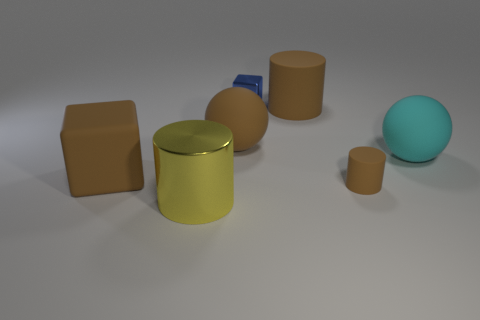Is there anything else that has the same color as the small cube?
Your response must be concise. No. There is a large brown rubber object that is to the left of the small blue object and to the right of the yellow object; what is its shape?
Make the answer very short. Sphere. Are there any things that are behind the tiny thing in front of the large object that is on the right side of the small brown matte thing?
Offer a very short reply. Yes. How many objects are either large objects in front of the small shiny block or brown matte objects right of the small blue metallic thing?
Ensure brevity in your answer.  6. Are the large cylinder that is behind the yellow metal thing and the tiny brown cylinder made of the same material?
Provide a succinct answer. Yes. What is the material of the object that is in front of the matte block and to the left of the tiny blue metal block?
Make the answer very short. Metal. There is a tiny thing that is in front of the rubber cube in front of the blue block; what color is it?
Keep it short and to the point. Brown. What material is the yellow thing that is the same shape as the tiny brown object?
Your answer should be very brief. Metal. What color is the block to the left of the large cylinder in front of the brown object on the left side of the yellow cylinder?
Your response must be concise. Brown. How many things are large brown spheres or cylinders?
Give a very brief answer. 4. 